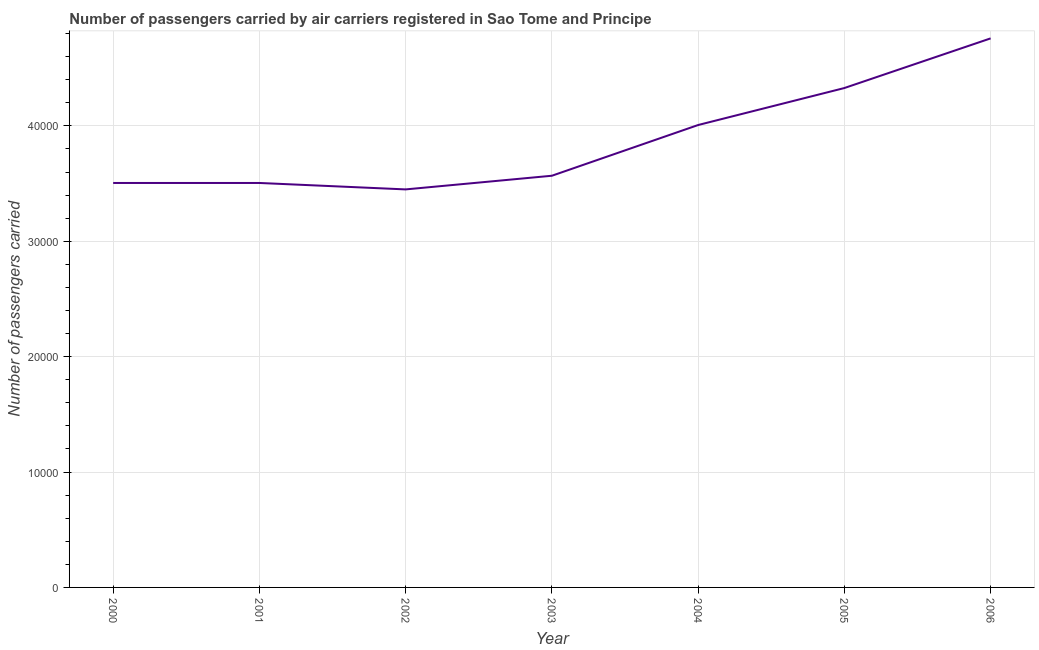What is the number of passengers carried in 2003?
Provide a succinct answer. 3.57e+04. Across all years, what is the maximum number of passengers carried?
Your answer should be compact. 4.76e+04. Across all years, what is the minimum number of passengers carried?
Your answer should be compact. 3.45e+04. In which year was the number of passengers carried minimum?
Offer a terse response. 2002. What is the sum of the number of passengers carried?
Your answer should be very brief. 2.71e+05. What is the difference between the number of passengers carried in 2001 and 2003?
Make the answer very short. -626. What is the average number of passengers carried per year?
Keep it short and to the point. 3.87e+04. What is the median number of passengers carried?
Your answer should be very brief. 3.57e+04. Do a majority of the years between 2005 and 2002 (inclusive) have number of passengers carried greater than 32000 ?
Keep it short and to the point. Yes. What is the ratio of the number of passengers carried in 2001 to that in 2006?
Give a very brief answer. 0.74. Is the difference between the number of passengers carried in 2003 and 2006 greater than the difference between any two years?
Your answer should be very brief. No. What is the difference between the highest and the second highest number of passengers carried?
Make the answer very short. 4303. Is the sum of the number of passengers carried in 2001 and 2004 greater than the maximum number of passengers carried across all years?
Ensure brevity in your answer.  Yes. What is the difference between the highest and the lowest number of passengers carried?
Offer a very short reply. 1.31e+04. In how many years, is the number of passengers carried greater than the average number of passengers carried taken over all years?
Offer a very short reply. 3. Does the number of passengers carried monotonically increase over the years?
Your answer should be compact. No. How many years are there in the graph?
Keep it short and to the point. 7. What is the difference between two consecutive major ticks on the Y-axis?
Give a very brief answer. 10000. What is the title of the graph?
Ensure brevity in your answer.  Number of passengers carried by air carriers registered in Sao Tome and Principe. What is the label or title of the X-axis?
Make the answer very short. Year. What is the label or title of the Y-axis?
Give a very brief answer. Number of passengers carried. What is the Number of passengers carried of 2000?
Provide a short and direct response. 3.51e+04. What is the Number of passengers carried of 2001?
Provide a short and direct response. 3.51e+04. What is the Number of passengers carried of 2002?
Your answer should be compact. 3.45e+04. What is the Number of passengers carried of 2003?
Give a very brief answer. 3.57e+04. What is the Number of passengers carried in 2004?
Your response must be concise. 4.01e+04. What is the Number of passengers carried of 2005?
Offer a terse response. 4.33e+04. What is the Number of passengers carried in 2006?
Your response must be concise. 4.76e+04. What is the difference between the Number of passengers carried in 2000 and 2001?
Give a very brief answer. 0. What is the difference between the Number of passengers carried in 2000 and 2002?
Provide a short and direct response. 558. What is the difference between the Number of passengers carried in 2000 and 2003?
Keep it short and to the point. -626. What is the difference between the Number of passengers carried in 2000 and 2004?
Provide a short and direct response. -5022. What is the difference between the Number of passengers carried in 2000 and 2005?
Make the answer very short. -8228. What is the difference between the Number of passengers carried in 2000 and 2006?
Your response must be concise. -1.25e+04. What is the difference between the Number of passengers carried in 2001 and 2002?
Offer a very short reply. 558. What is the difference between the Number of passengers carried in 2001 and 2003?
Your answer should be compact. -626. What is the difference between the Number of passengers carried in 2001 and 2004?
Your answer should be very brief. -5022. What is the difference between the Number of passengers carried in 2001 and 2005?
Your response must be concise. -8228. What is the difference between the Number of passengers carried in 2001 and 2006?
Provide a short and direct response. -1.25e+04. What is the difference between the Number of passengers carried in 2002 and 2003?
Ensure brevity in your answer.  -1184. What is the difference between the Number of passengers carried in 2002 and 2004?
Provide a short and direct response. -5580. What is the difference between the Number of passengers carried in 2002 and 2005?
Keep it short and to the point. -8786. What is the difference between the Number of passengers carried in 2002 and 2006?
Give a very brief answer. -1.31e+04. What is the difference between the Number of passengers carried in 2003 and 2004?
Your answer should be compact. -4396. What is the difference between the Number of passengers carried in 2003 and 2005?
Offer a very short reply. -7602. What is the difference between the Number of passengers carried in 2003 and 2006?
Make the answer very short. -1.19e+04. What is the difference between the Number of passengers carried in 2004 and 2005?
Your response must be concise. -3206. What is the difference between the Number of passengers carried in 2004 and 2006?
Your response must be concise. -7509. What is the difference between the Number of passengers carried in 2005 and 2006?
Provide a succinct answer. -4303. What is the ratio of the Number of passengers carried in 2000 to that in 2002?
Offer a terse response. 1.02. What is the ratio of the Number of passengers carried in 2000 to that in 2003?
Give a very brief answer. 0.98. What is the ratio of the Number of passengers carried in 2000 to that in 2004?
Ensure brevity in your answer.  0.88. What is the ratio of the Number of passengers carried in 2000 to that in 2005?
Provide a succinct answer. 0.81. What is the ratio of the Number of passengers carried in 2000 to that in 2006?
Your answer should be very brief. 0.74. What is the ratio of the Number of passengers carried in 2001 to that in 2002?
Ensure brevity in your answer.  1.02. What is the ratio of the Number of passengers carried in 2001 to that in 2005?
Provide a succinct answer. 0.81. What is the ratio of the Number of passengers carried in 2001 to that in 2006?
Your response must be concise. 0.74. What is the ratio of the Number of passengers carried in 2002 to that in 2003?
Provide a succinct answer. 0.97. What is the ratio of the Number of passengers carried in 2002 to that in 2004?
Make the answer very short. 0.86. What is the ratio of the Number of passengers carried in 2002 to that in 2005?
Ensure brevity in your answer.  0.8. What is the ratio of the Number of passengers carried in 2002 to that in 2006?
Your response must be concise. 0.72. What is the ratio of the Number of passengers carried in 2003 to that in 2004?
Ensure brevity in your answer.  0.89. What is the ratio of the Number of passengers carried in 2003 to that in 2005?
Make the answer very short. 0.82. What is the ratio of the Number of passengers carried in 2004 to that in 2005?
Offer a very short reply. 0.93. What is the ratio of the Number of passengers carried in 2004 to that in 2006?
Your answer should be compact. 0.84. What is the ratio of the Number of passengers carried in 2005 to that in 2006?
Ensure brevity in your answer.  0.91. 